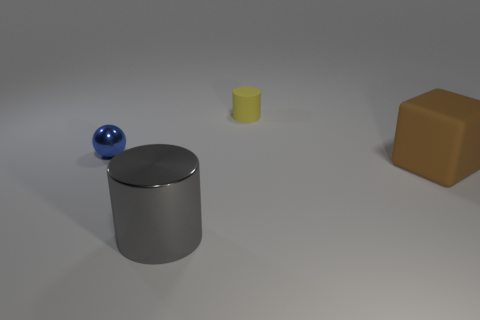How would you describe the lighting in this scene? The lighting in this scene appears to be diffuse and soft, likely coming from a wide light source above, casting subtle shadows beneath the objects, which suggests an indoor setting with ambient lighting. 